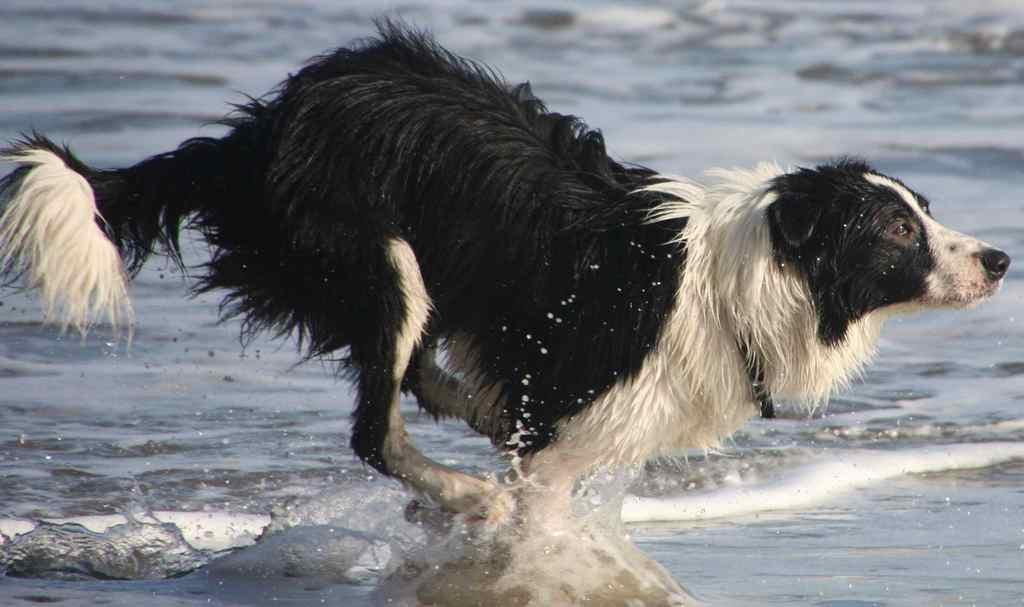What is the main subject in the center of the image? There is a dog in the center of the image. What can be seen at the bottom of the image? There is water visible at the bottom of the image. What type of trail can be seen in the image? There is no trail present in the image; it features a dog and water. What kind of pipe is visible in the image? There is no pipe present in the image. 